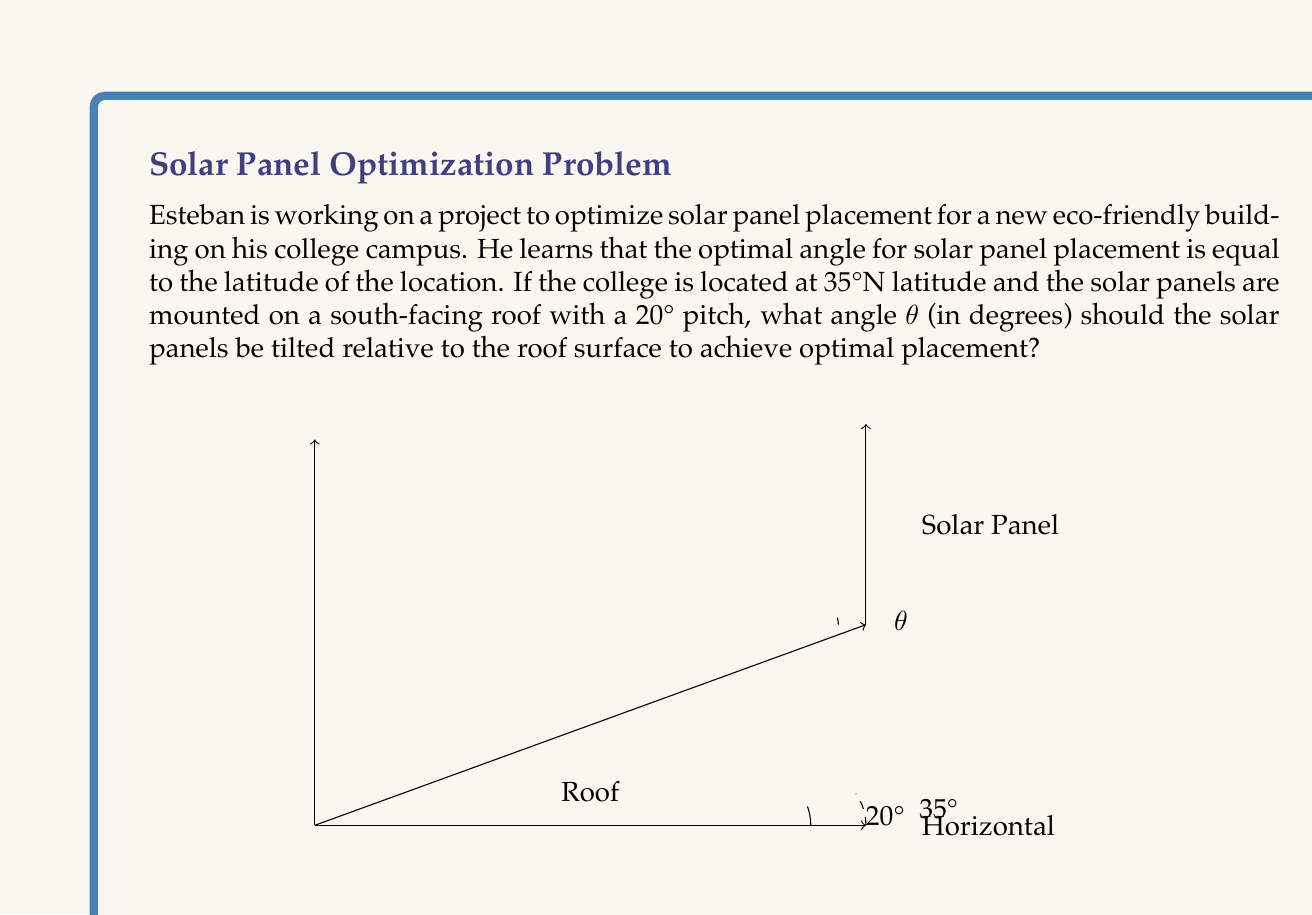Can you answer this question? To solve this problem, let's break it down into steps:

1) The optimal angle for solar panel placement is equal to the latitude, which is 35° in this case.

2) The roof already has a pitch of 20°. We need to find the additional angle $\theta$ needed to reach the optimal 35° from horizontal.

3) We can set up an equation:
   
   $20° + \theta = 35°$

4) Solving for $\theta$:
   
   $\theta = 35° - 20° = 15°$

5) To verify, we can use trigonometric functions:
   
   Let's consider a right triangle formed by the solar panel and the roof surface.
   
   $$\tan(\theta) = \frac{\text{opposite}}{\text{adjacent}} = \frac{\text{additional height}}{\text{length of roof surface}}$$

   The angle between the horizontal and the optimal panel position is 35°, so:
   
   $$\tan(35°) = \frac{\text{total height}}{\text{length of roof surface}}$$

   The angle between the horizontal and the roof is 20°, so:
   
   $$\tan(20°) = \frac{\text{roof height}}{\text{length of roof surface}}$$

   The difference between these two tangents will give us $\tan(\theta)$:
   
   $$\tan(\theta) = \tan(35°) - \tan(20°) = 0.7002 - 0.3640 = 0.3362$$

   Using the inverse tangent function:
   
   $$\theta = \tan^{-1}(0.3362) \approx 15.0°$$

This confirms our initial calculation.
Answer: The solar panels should be tilted at an angle of $15°$ relative to the roof surface. 